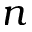<formula> <loc_0><loc_0><loc_500><loc_500>n</formula> 